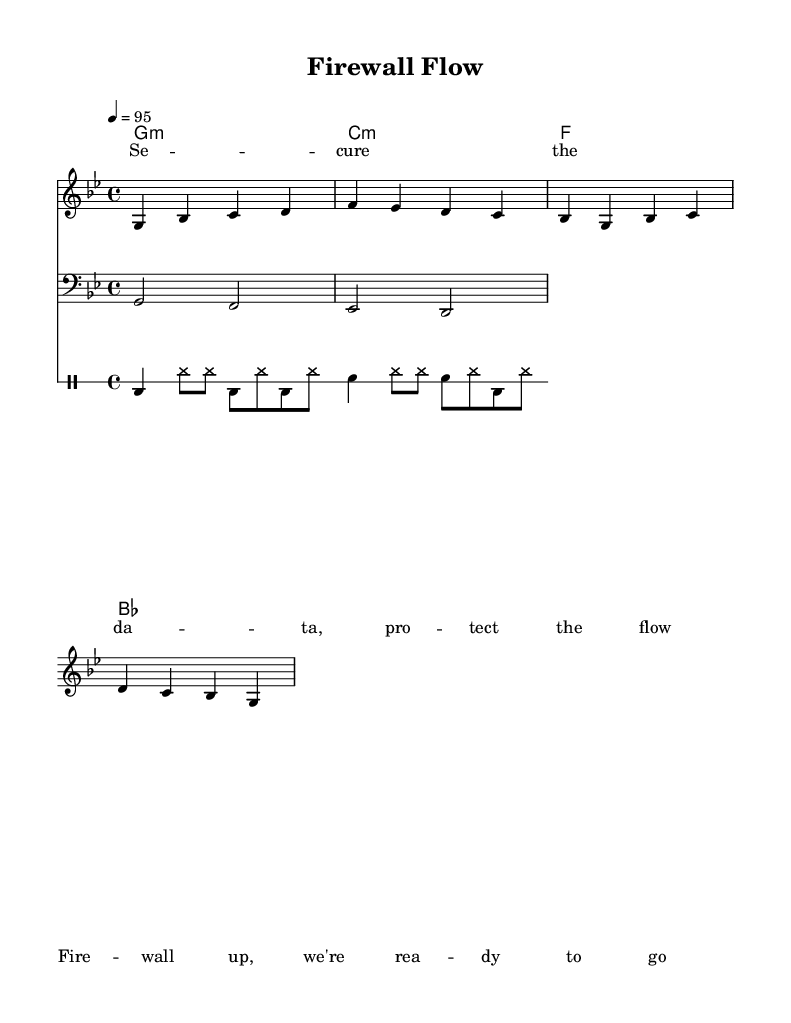What is the key signature of this music? The key signature is one flat, which indicates that the piece is in G minor. G minor consists of the notes G, A, B-flat, C, D, E-flat, and F.
Answer: G minor What is the time signature of this music? The time signature is four-four, indicating that each measure contains four beats, and the quarter note gets one beat. This is a common time signature in many music genres, including hip hop.
Answer: 4/4 What is the tempo of this music? The tempo is set at 95 beats per minute, which is a moderate pace suitable for an upbeat rap song. This can be inferred from the tempo marking at the beginning of the score.
Answer: 95 What instruments are used in this piece? The piece includes a melody voice, bass voice, and drums, which are common components in hip hop music and provide a rhythmic and melodic structure.
Answer: Melody, bass, drums Explain the rhythmic structure of the melody. The melody includes a combination of quarter notes and eighth notes, creating a syncopated rhythm that is characteristic of hip hop music. The varying note lengths contribute to a dynamic flow.
Answer: Syncopated rhythm What is the main theme conveyed in the lyrics? The lyrics emphasize themes of data protection and cybersecurity, highlighting the importance of securing information and being prepared, which resonates with contemporary issues related to technology.
Answer: Data protection 